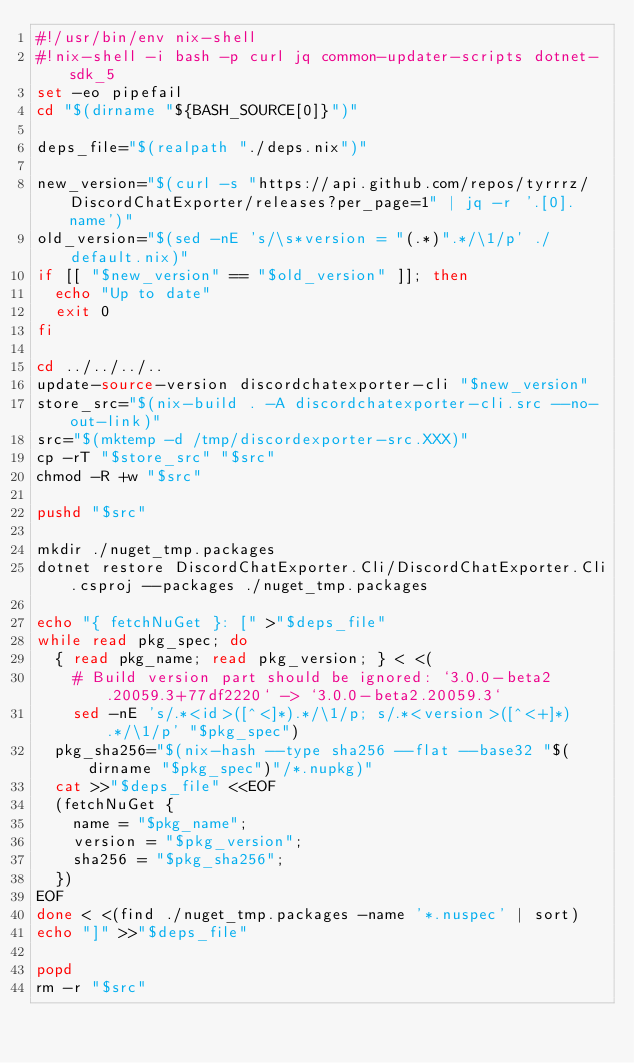<code> <loc_0><loc_0><loc_500><loc_500><_Bash_>#!/usr/bin/env nix-shell
#!nix-shell -i bash -p curl jq common-updater-scripts dotnet-sdk_5
set -eo pipefail
cd "$(dirname "${BASH_SOURCE[0]}")"

deps_file="$(realpath "./deps.nix")"

new_version="$(curl -s "https://api.github.com/repos/tyrrrz/DiscordChatExporter/releases?per_page=1" | jq -r '.[0].name')"
old_version="$(sed -nE 's/\s*version = "(.*)".*/\1/p' ./default.nix)"
if [[ "$new_version" == "$old_version" ]]; then
  echo "Up to date"
  exit 0
fi

cd ../../../..
update-source-version discordchatexporter-cli "$new_version"
store_src="$(nix-build . -A discordchatexporter-cli.src --no-out-link)"
src="$(mktemp -d /tmp/discordexporter-src.XXX)"
cp -rT "$store_src" "$src"
chmod -R +w "$src"

pushd "$src"

mkdir ./nuget_tmp.packages
dotnet restore DiscordChatExporter.Cli/DiscordChatExporter.Cli.csproj --packages ./nuget_tmp.packages

echo "{ fetchNuGet }: [" >"$deps_file"
while read pkg_spec; do
  { read pkg_name; read pkg_version; } < <(
    # Build version part should be ignored: `3.0.0-beta2.20059.3+77df2220` -> `3.0.0-beta2.20059.3`
    sed -nE 's/.*<id>([^<]*).*/\1/p; s/.*<version>([^<+]*).*/\1/p' "$pkg_spec")
  pkg_sha256="$(nix-hash --type sha256 --flat --base32 "$(dirname "$pkg_spec")"/*.nupkg)"
  cat >>"$deps_file" <<EOF
  (fetchNuGet {
    name = "$pkg_name";
    version = "$pkg_version";
    sha256 = "$pkg_sha256";
  })
EOF
done < <(find ./nuget_tmp.packages -name '*.nuspec' | sort)
echo "]" >>"$deps_file"

popd
rm -r "$src"
</code> 